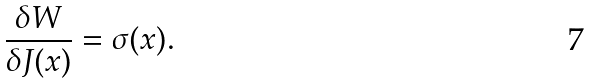<formula> <loc_0><loc_0><loc_500><loc_500>\frac { \delta W } { \delta J ( x ) } = \sigma ( x ) .</formula> 